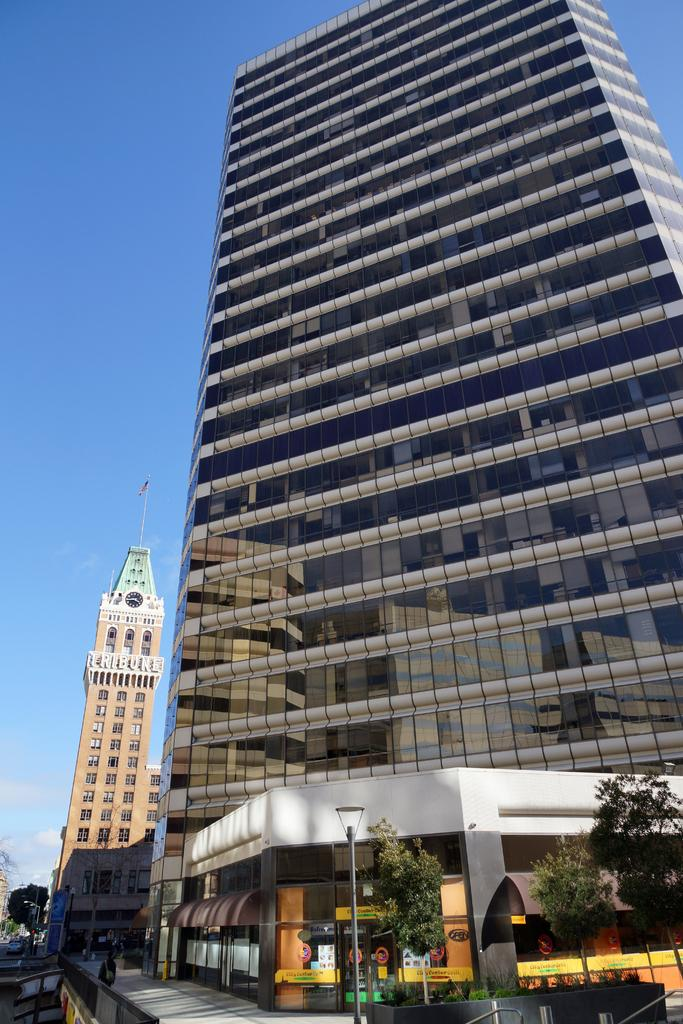What type of structures can be seen in the image? There are buildings in the image. What is the flag attached to in the image? The flag is attached to a pole in the image. What type of vegetation is present in the image? There are trees and grass in the image. What is separating the grass and trees from the buildings in the image? There is a fence in the image. What is the board used for in the image? The purpose of the board in the image cannot be determined from the facts provided. What is visible in the sky in the image? The sky is visible in the image, but no specific details about the sky can be determined from the facts provided. Can you see any mountains or yaks in the image? No, there are no mountains or yaks present in the image. What type of card is being used to play a game in the image? There is no card or game present in the image. 